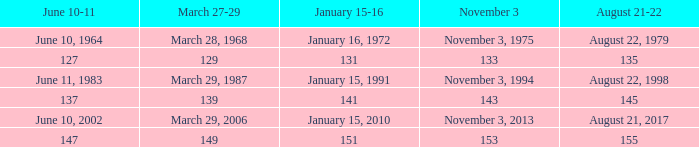 november 3 where march 27-29 is 149? 153.0. 